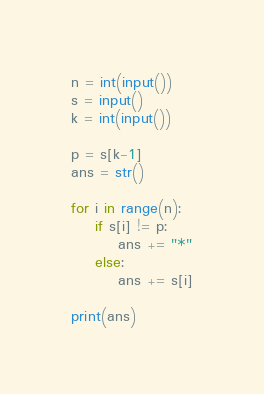<code> <loc_0><loc_0><loc_500><loc_500><_Python_>n = int(input())
s = input()
k = int(input())

p = s[k-1]
ans = str()

for i in range(n):
    if s[i] != p:
        ans += "*"
    else:
        ans += s[i]

print(ans)</code> 